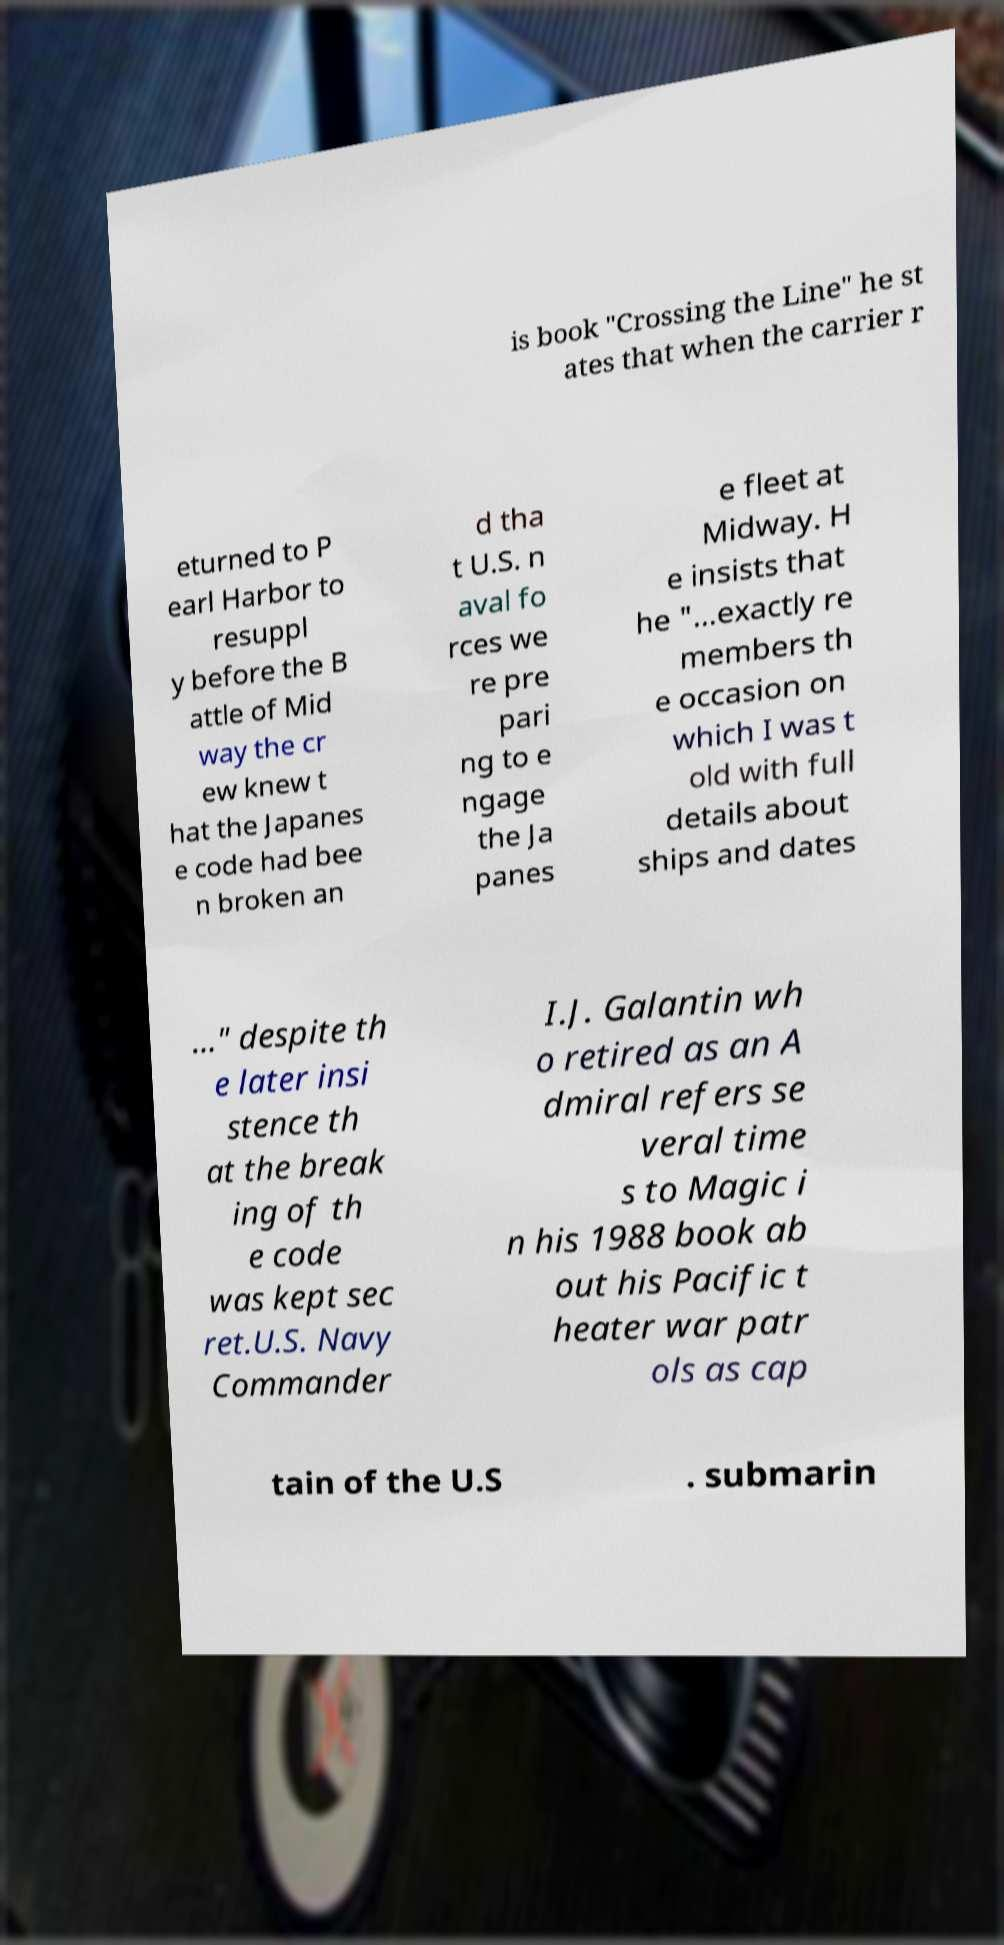For documentation purposes, I need the text within this image transcribed. Could you provide that? is book "Crossing the Line" he st ates that when the carrier r eturned to P earl Harbor to resuppl y before the B attle of Mid way the cr ew knew t hat the Japanes e code had bee n broken an d tha t U.S. n aval fo rces we re pre pari ng to e ngage the Ja panes e fleet at Midway. H e insists that he "…exactly re members th e occasion on which I was t old with full details about ships and dates …" despite th e later insi stence th at the break ing of th e code was kept sec ret.U.S. Navy Commander I.J. Galantin wh o retired as an A dmiral refers se veral time s to Magic i n his 1988 book ab out his Pacific t heater war patr ols as cap tain of the U.S . submarin 